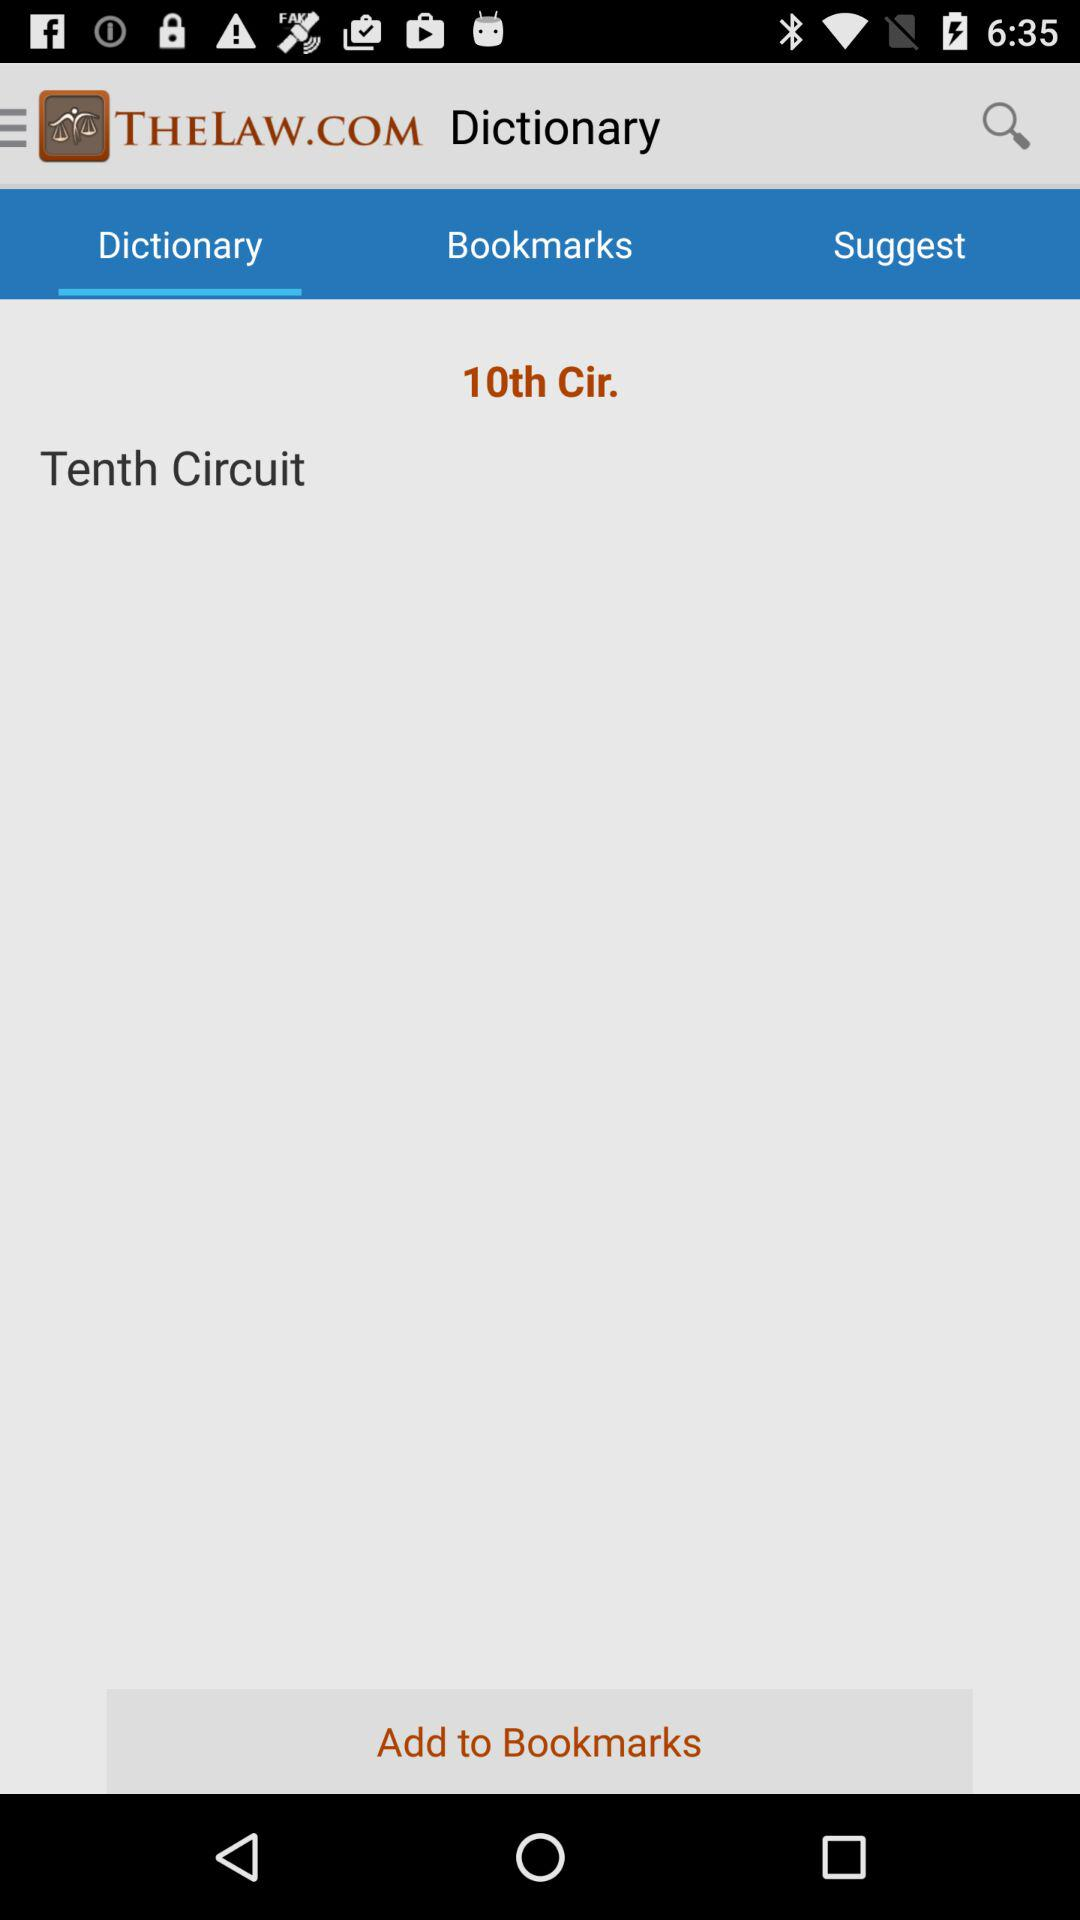Which word is written in the "Dictionary" option? The word written in the "Dictionary" option is Tenth Circuit. 